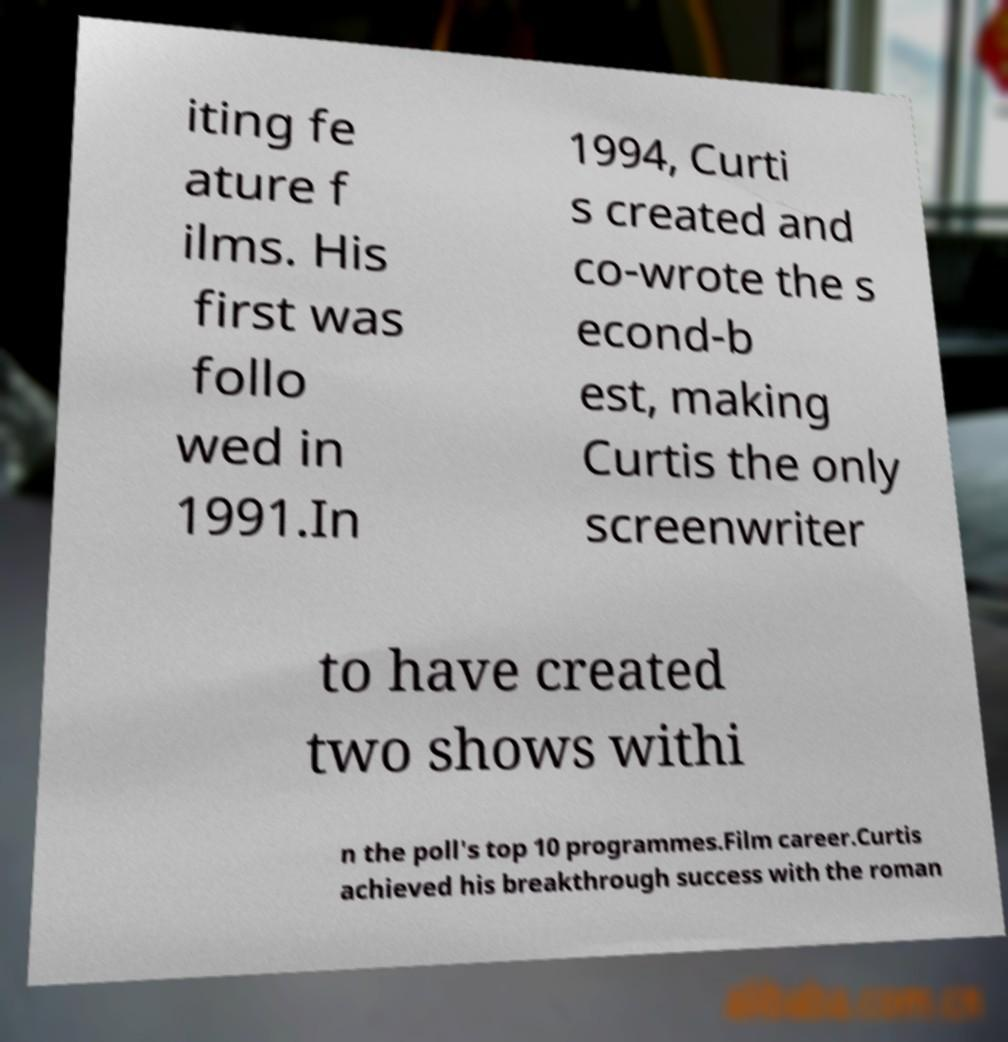Could you assist in decoding the text presented in this image and type it out clearly? iting fe ature f ilms. His first was follo wed in 1991.In 1994, Curti s created and co-wrote the s econd-b est, making Curtis the only screenwriter to have created two shows withi n the poll's top 10 programmes.Film career.Curtis achieved his breakthrough success with the roman 